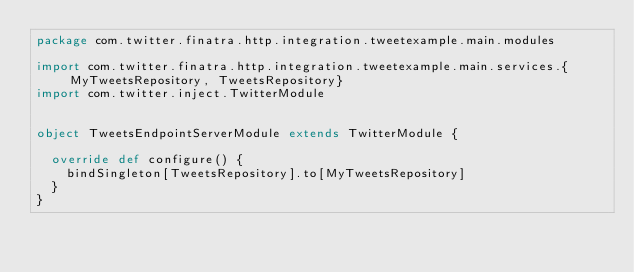Convert code to text. <code><loc_0><loc_0><loc_500><loc_500><_Scala_>package com.twitter.finatra.http.integration.tweetexample.main.modules

import com.twitter.finatra.http.integration.tweetexample.main.services.{MyTweetsRepository, TweetsRepository}
import com.twitter.inject.TwitterModule


object TweetsEndpointServerModule extends TwitterModule {

  override def configure() {
    bindSingleton[TweetsRepository].to[MyTweetsRepository]
  }
}
</code> 